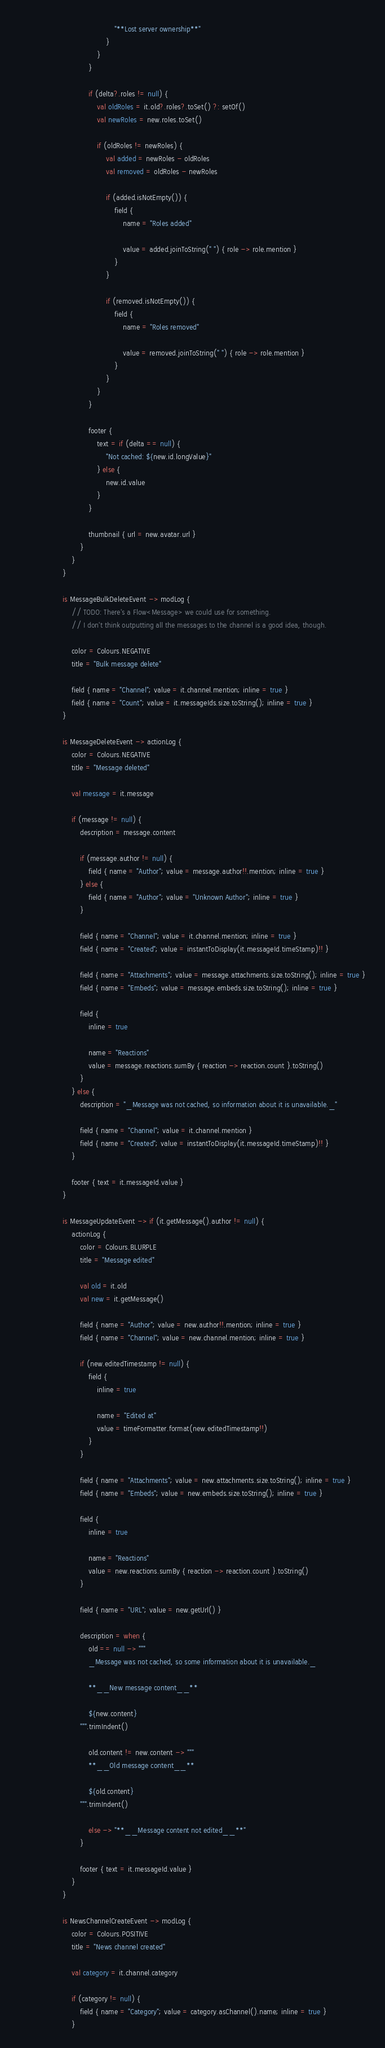Convert code to text. <code><loc_0><loc_0><loc_500><loc_500><_Kotlin_>                                            "**Lost server ownership**"
                                        }
                                    }
                                }

                                if (delta?.roles != null) {
                                    val oldRoles = it.old?.roles?.toSet() ?: setOf()
                                    val newRoles = new.roles.toSet()

                                    if (oldRoles != newRoles) {
                                        val added = newRoles - oldRoles
                                        val removed = oldRoles - newRoles

                                        if (added.isNotEmpty()) {
                                            field {
                                                name = "Roles added"

                                                value = added.joinToString(" ") { role -> role.mention }
                                            }
                                        }

                                        if (removed.isNotEmpty()) {
                                            field {
                                                name = "Roles removed"

                                                value = removed.joinToString(" ") { role -> role.mention }
                                            }
                                        }
                                    }
                                }

                                footer {
                                    text = if (delta == null) {
                                        "Not cached: ${new.id.longValue}"
                                    } else {
                                        new.id.value
                                    }
                                }

                                thumbnail { url = new.avatar.url }
                            }
                        }
                    }

                    is MessageBulkDeleteEvent -> modLog {
                        // TODO: There's a Flow<Message> we could use for something.
                        // I don't think outputting all the messages to the channel is a good idea, though.

                        color = Colours.NEGATIVE
                        title = "Bulk message delete"

                        field { name = "Channel"; value = it.channel.mention; inline = true }
                        field { name = "Count"; value = it.messageIds.size.toString(); inline = true }
                    }

                    is MessageDeleteEvent -> actionLog {
                        color = Colours.NEGATIVE
                        title = "Message deleted"

                        val message = it.message

                        if (message != null) {
                            description = message.content

                            if (message.author != null) {
                                field { name = "Author"; value = message.author!!.mention; inline = true }
                            } else {
                                field { name = "Author"; value = "Unknown Author"; inline = true }
                            }

                            field { name = "Channel"; value = it.channel.mention; inline = true }
                            field { name = "Created"; value = instantToDisplay(it.messageId.timeStamp)!! }

                            field { name = "Attachments"; value = message.attachments.size.toString(); inline = true }
                            field { name = "Embeds"; value = message.embeds.size.toString(); inline = true }

                            field {
                                inline = true

                                name = "Reactions"
                                value = message.reactions.sumBy { reaction -> reaction.count }.toString()
                            }
                        } else {
                            description = "_Message was not cached, so information about it is unavailable._"

                            field { name = "Channel"; value = it.channel.mention }
                            field { name = "Created"; value = instantToDisplay(it.messageId.timeStamp)!! }
                        }

                        footer { text = it.messageId.value }
                    }

                    is MessageUpdateEvent -> if (it.getMessage().author != null) {
                        actionLog {
                            color = Colours.BLURPLE
                            title = "Message edited"

                            val old = it.old
                            val new = it.getMessage()

                            field { name = "Author"; value = new.author!!.mention; inline = true }
                            field { name = "Channel"; value = new.channel.mention; inline = true }

                            if (new.editedTimestamp != null) {
                                field {
                                    inline = true

                                    name = "Edited at"
                                    value = timeFormatter.format(new.editedTimestamp!!)
                                }
                            }

                            field { name = "Attachments"; value = new.attachments.size.toString(); inline = true }
                            field { name = "Embeds"; value = new.embeds.size.toString(); inline = true }

                            field {
                                inline = true

                                name = "Reactions"
                                value = new.reactions.sumBy { reaction -> reaction.count }.toString()
                            }

                            field { name = "URL"; value = new.getUrl() }

                            description = when {
                                old == null -> """
                                _Message was not cached, so some information about it is unavailable._
                                
                                **__New message content__**

                                ${new.content}
                            """.trimIndent()

                                old.content != new.content -> """
                                **__Old message content__**

                                ${old.content}
                            """.trimIndent()

                                else -> "**__Message content not edited__**"
                            }

                            footer { text = it.messageId.value }
                        }
                    }

                    is NewsChannelCreateEvent -> modLog {
                        color = Colours.POSITIVE
                        title = "News channel created"

                        val category = it.channel.category

                        if (category != null) {
                            field { name = "Category"; value = category.asChannel().name; inline = true }
                        }
</code> 